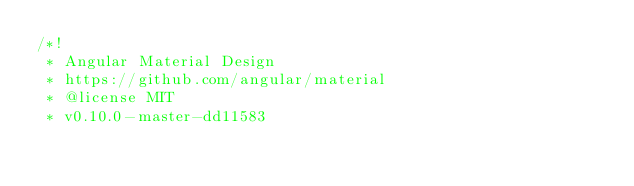<code> <loc_0><loc_0><loc_500><loc_500><_CSS_>/*!
 * Angular Material Design
 * https://github.com/angular/material
 * @license MIT
 * v0.10.0-master-dd11583</code> 